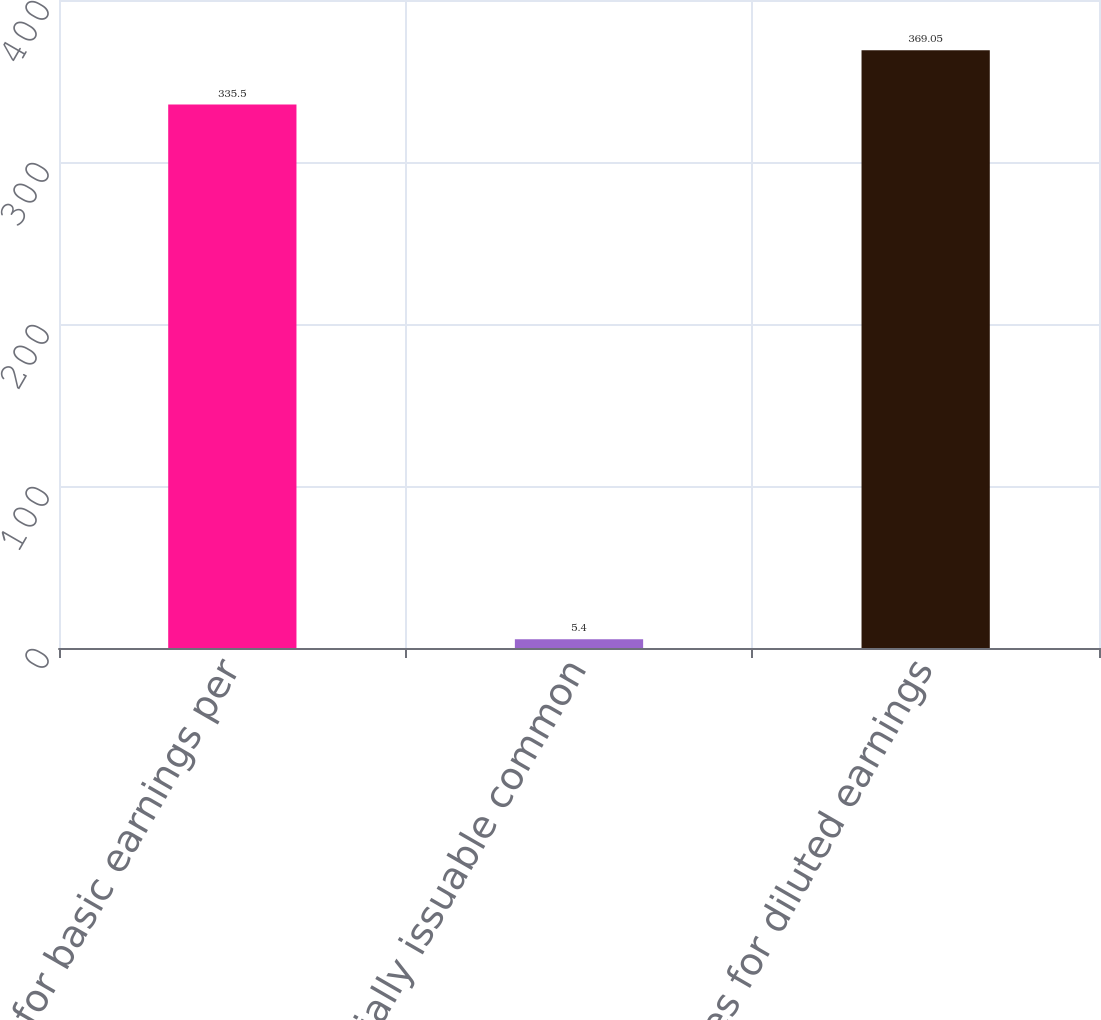<chart> <loc_0><loc_0><loc_500><loc_500><bar_chart><fcel>Shares for basic earnings per<fcel>Potentially issuable common<fcel>Shares for diluted earnings<nl><fcel>335.5<fcel>5.4<fcel>369.05<nl></chart> 